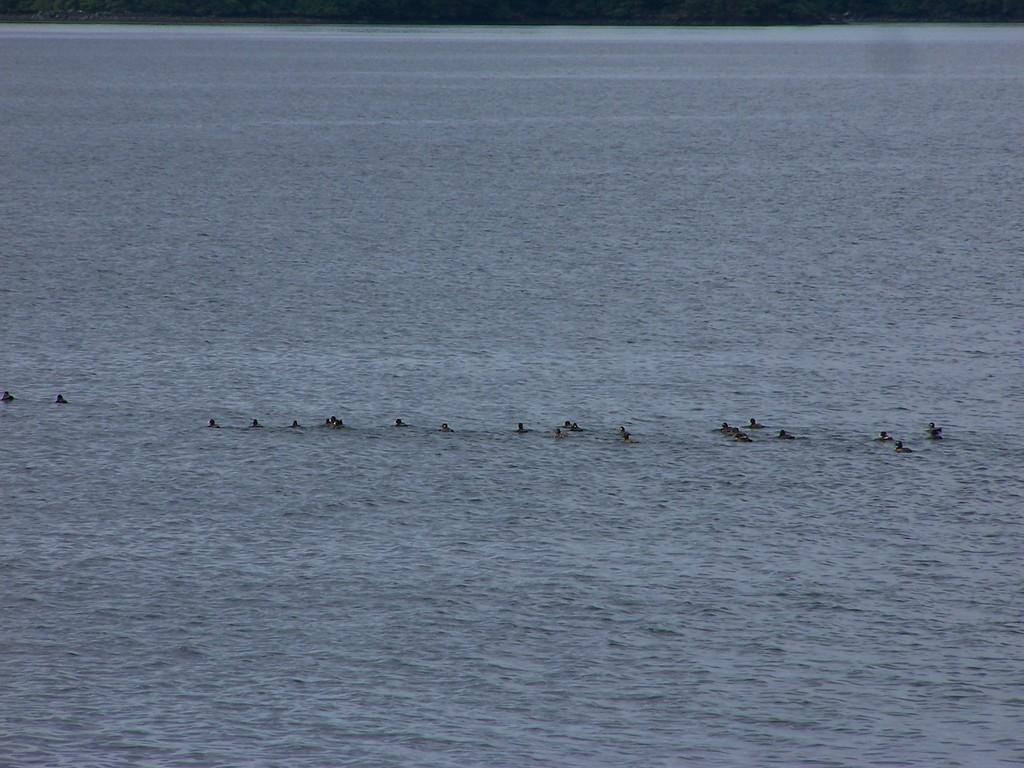What type of animals can be seen in the image? There is a group of birds in the image. Where are the birds located in the image? The birds are in the water. What type of frame is surrounding the birds in the image? There is no frame surrounding the birds in the image; they are in the water. How many cars can be seen in the image? There are no cars present in the image; it features a group of birds in the water. 